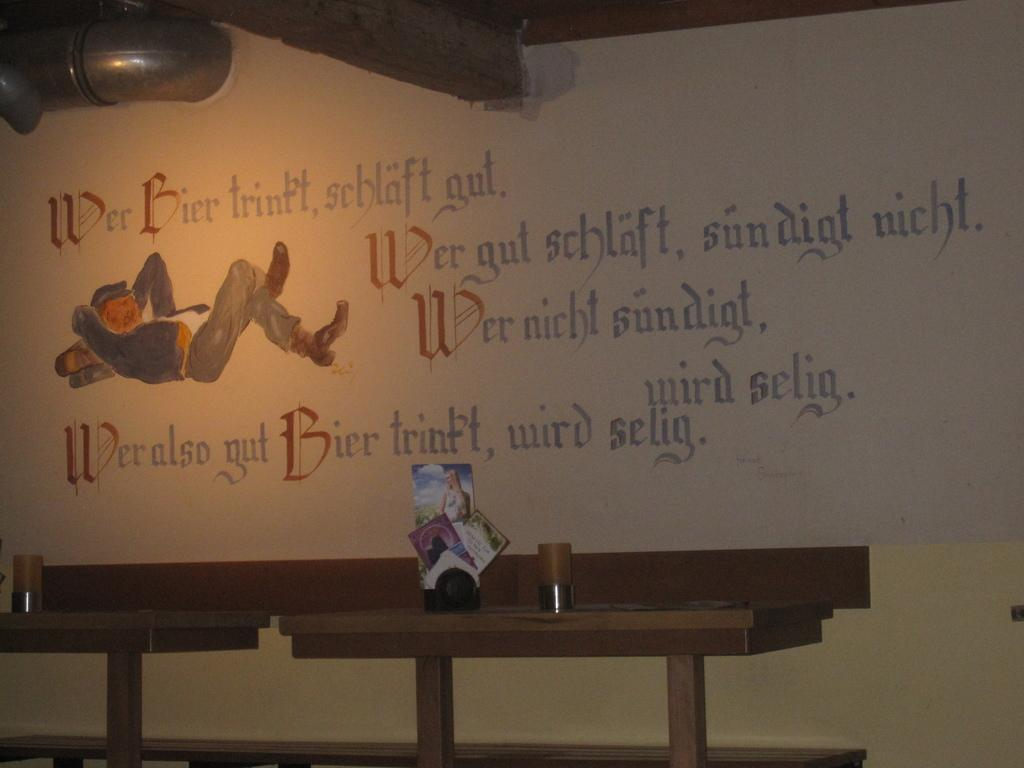<image>
Summarize the visual content of the image. A white bar sign with words like Bier and wird selig on it 